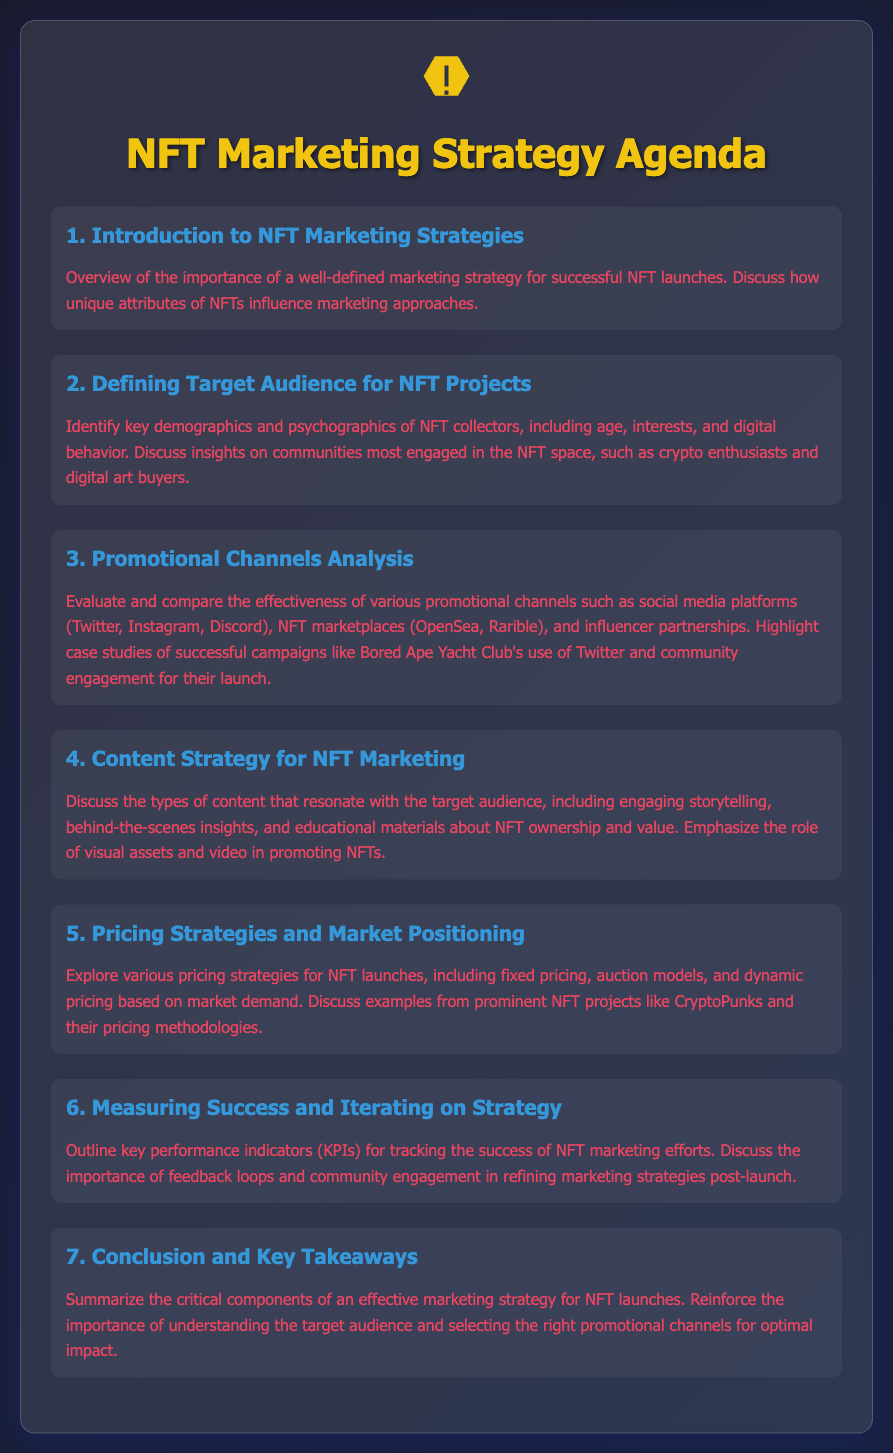What is the title of the agenda? The title is stated prominently at the top of the document, which is "NFT Marketing Strategy Agenda."
Answer: NFT Marketing Strategy Agenda What is discussed in the first agenda item? The first agenda item gives an overview of NFT marketing strategies and the importance of having a well-defined strategy.
Answer: Importance of a well-defined marketing strategy What is one demographic identified in the second agenda item? The second agenda item highlights key demographics of NFT collectors, one of which is age.
Answer: Age Which social media platform is mentioned in the promotional channels analysis? The document mentions several social media platforms for promotional analysis, including one like Twitter.
Answer: Twitter What type of content is emphasized in the content strategy for NFT marketing? The content strategy emphasizes engaging storytelling as a key type of content for NFT marketing.
Answer: Engaging storytelling What are two pricing strategies explored in the fifth agenda item? The fifth agenda item discusses fixed pricing and auction models as two strategies for NFT launches.
Answer: Fixed pricing, auction models What is highlighted as crucial in measuring success and refining strategies? In measuring success, feedback loops and community engagement are highlighted as crucial elements.
Answer: Feedback loops and community engagement What is the main subject of the conclusion in the agenda? The conclusion summarizes critical components for an effective marketing strategy for NFT launches, emphasizing target audience understanding.
Answer: Effective marketing strategy components 